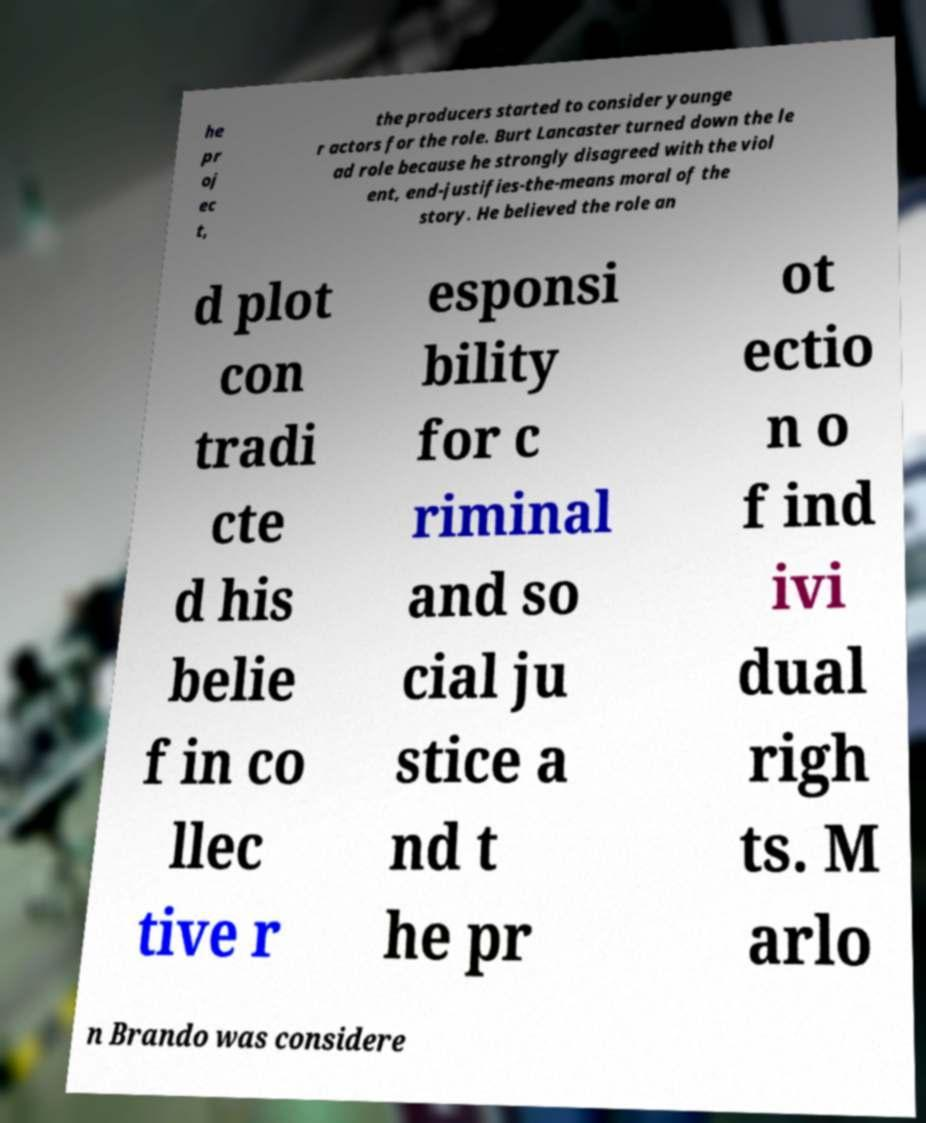What messages or text are displayed in this image? I need them in a readable, typed format. he pr oj ec t, the producers started to consider younge r actors for the role. Burt Lancaster turned down the le ad role because he strongly disagreed with the viol ent, end-justifies-the-means moral of the story. He believed the role an d plot con tradi cte d his belie f in co llec tive r esponsi bility for c riminal and so cial ju stice a nd t he pr ot ectio n o f ind ivi dual righ ts. M arlo n Brando was considere 